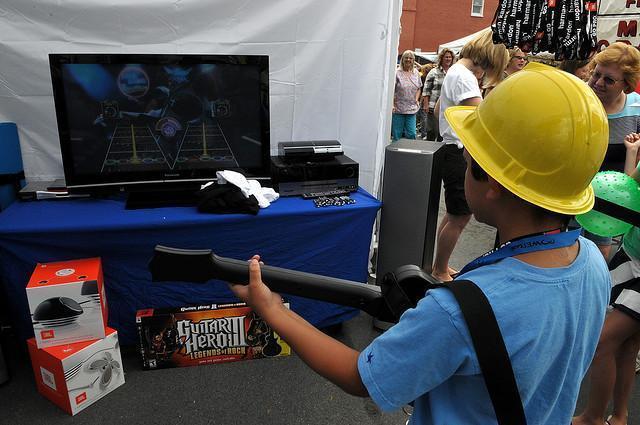How many people can you see?
Give a very brief answer. 4. How many zebras are shown?
Give a very brief answer. 0. 